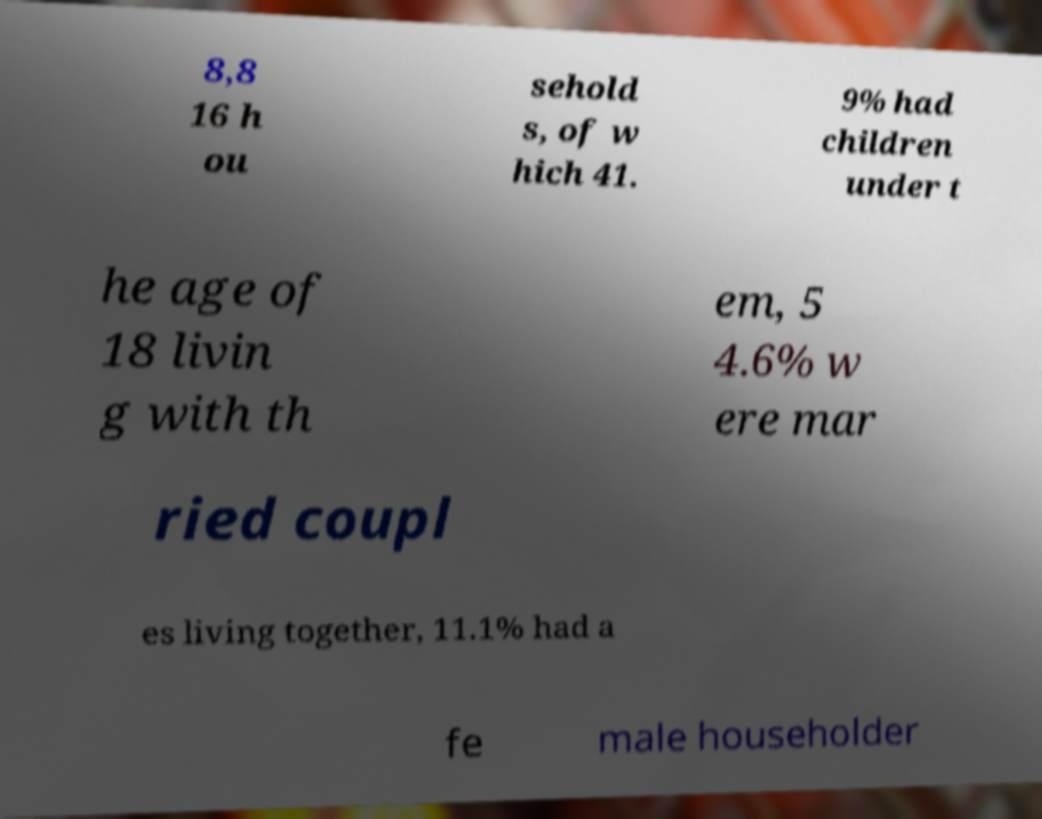I need the written content from this picture converted into text. Can you do that? 8,8 16 h ou sehold s, of w hich 41. 9% had children under t he age of 18 livin g with th em, 5 4.6% w ere mar ried coupl es living together, 11.1% had a fe male householder 